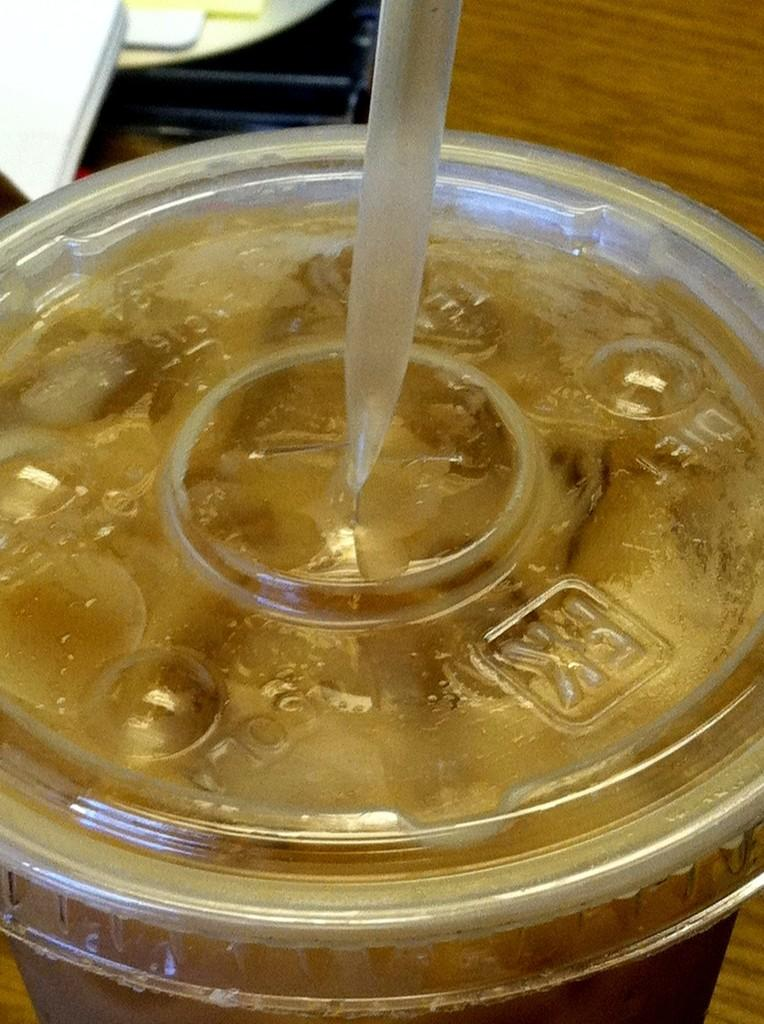What is in the glass that is visible in the image? There is a liquid in the glass, and it has a brown color. What else can be seen in the image besides the glass? There is a straw visible in the image. What is the color of the surface on which the glass is placed? The glass is on a brown surface. What riddle can be solved by looking at the salt in the image? There is no salt present in the image, so no riddle can be solved by looking at it. 